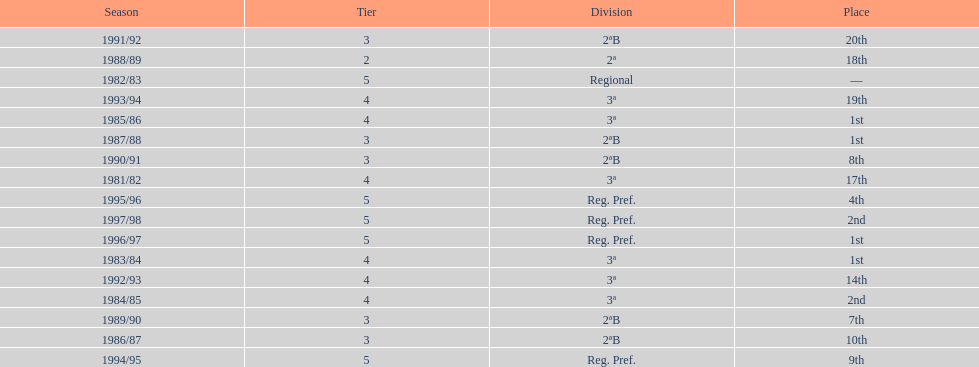How many years were they in tier 3 5. 